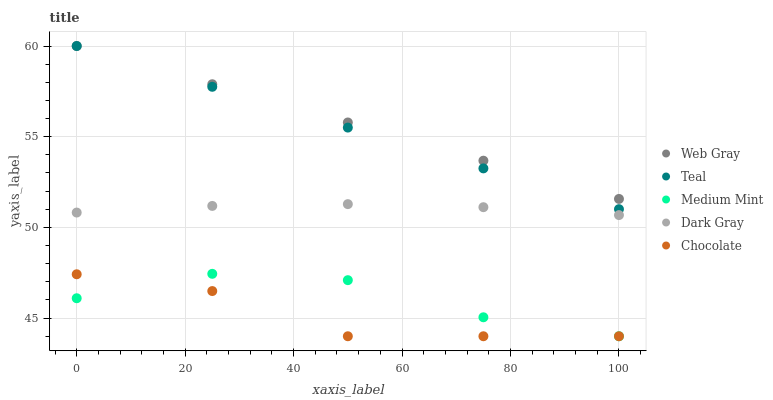Does Chocolate have the minimum area under the curve?
Answer yes or no. Yes. Does Web Gray have the maximum area under the curve?
Answer yes or no. Yes. Does Dark Gray have the minimum area under the curve?
Answer yes or no. No. Does Dark Gray have the maximum area under the curve?
Answer yes or no. No. Is Web Gray the smoothest?
Answer yes or no. Yes. Is Medium Mint the roughest?
Answer yes or no. Yes. Is Dark Gray the smoothest?
Answer yes or no. No. Is Dark Gray the roughest?
Answer yes or no. No. Does Medium Mint have the lowest value?
Answer yes or no. Yes. Does Dark Gray have the lowest value?
Answer yes or no. No. Does Teal have the highest value?
Answer yes or no. Yes. Does Dark Gray have the highest value?
Answer yes or no. No. Is Medium Mint less than Teal?
Answer yes or no. Yes. Is Dark Gray greater than Medium Mint?
Answer yes or no. Yes. Does Web Gray intersect Teal?
Answer yes or no. Yes. Is Web Gray less than Teal?
Answer yes or no. No. Is Web Gray greater than Teal?
Answer yes or no. No. Does Medium Mint intersect Teal?
Answer yes or no. No. 